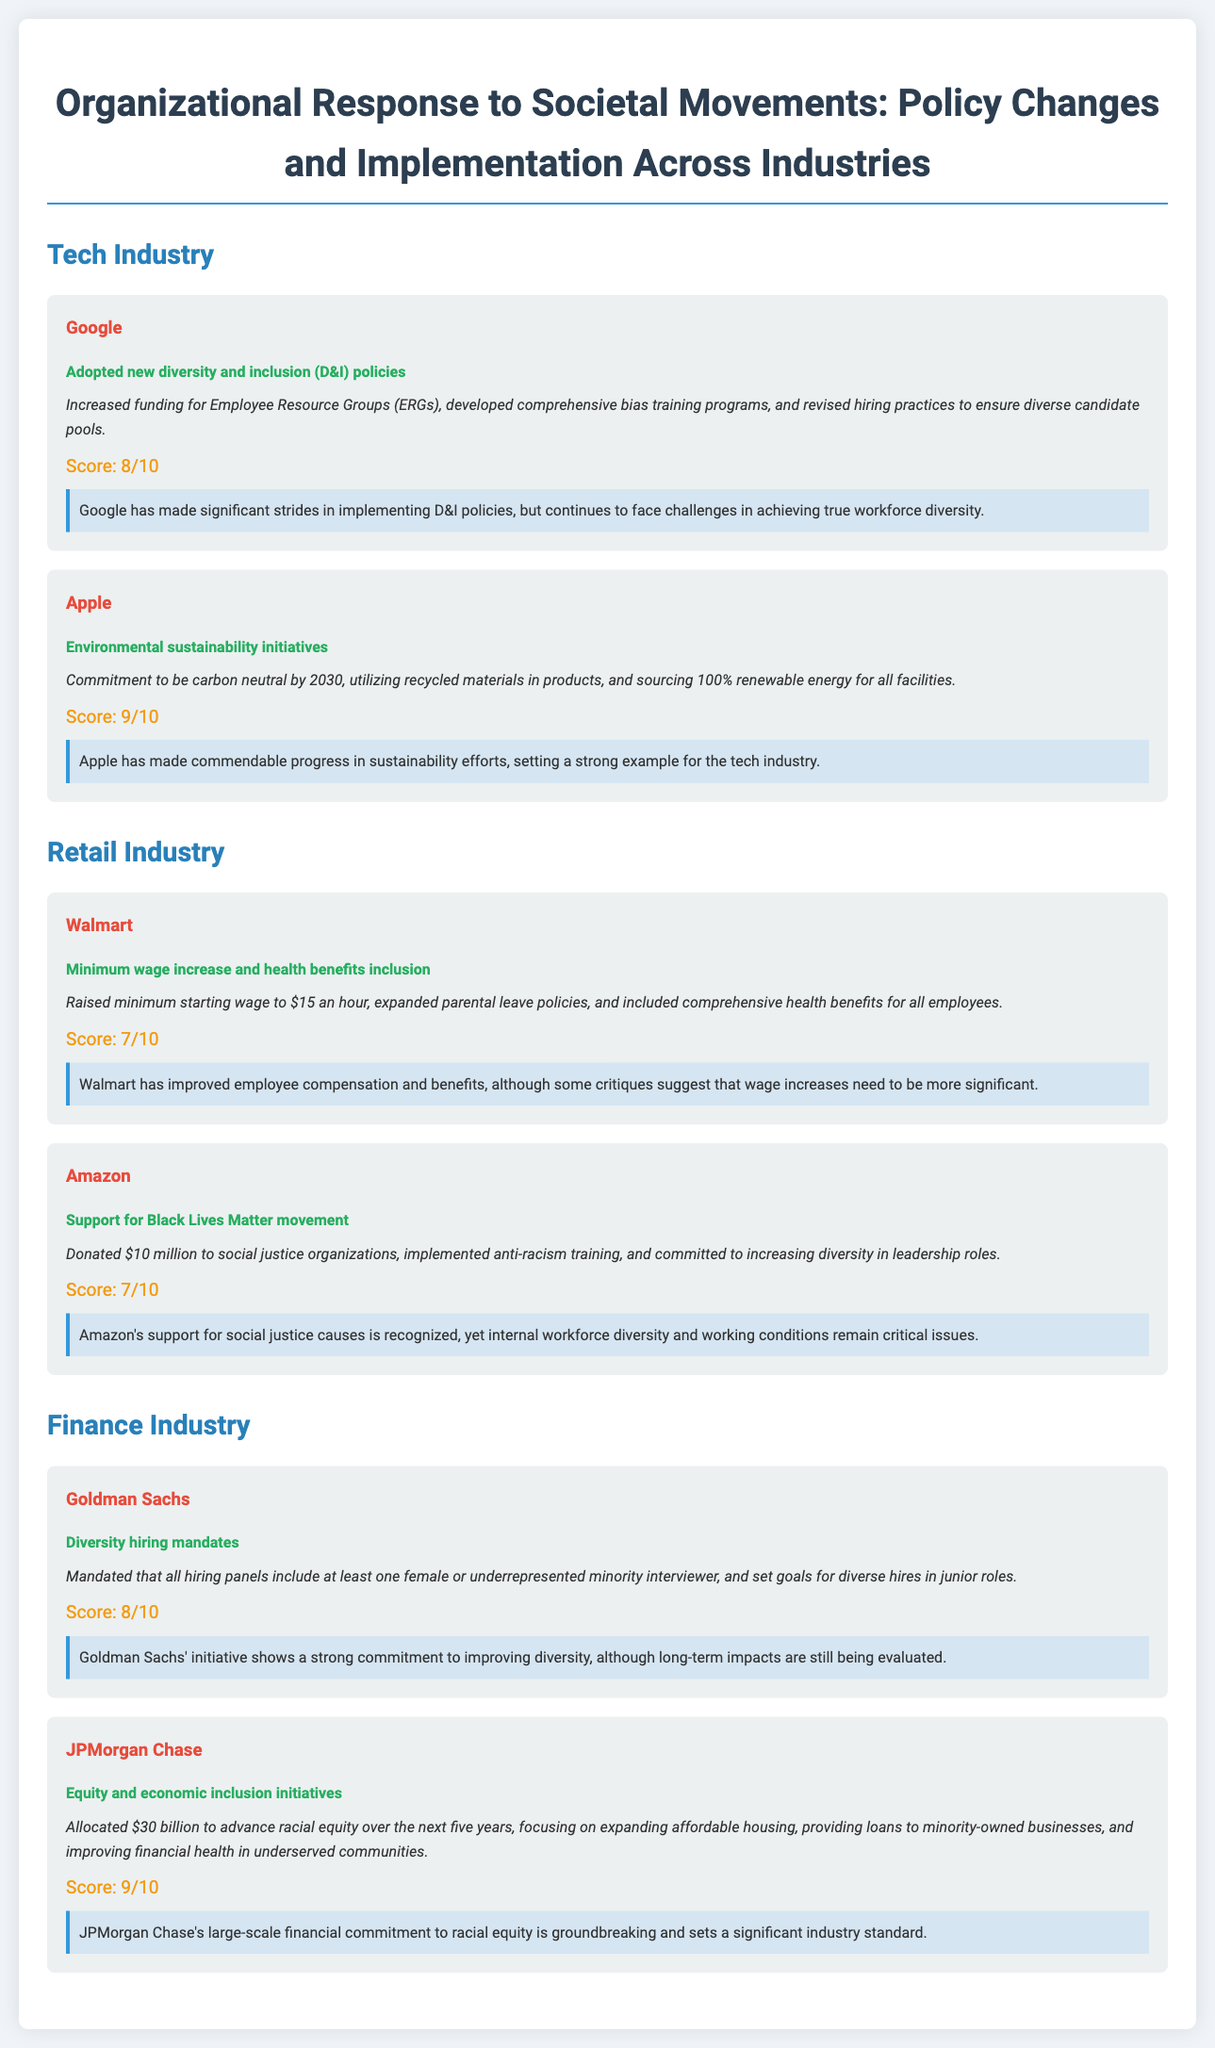What is the score for Google? The score for Google, as indicated in the document, is based on the assessment of their diversity and inclusion policies.
Answer: 8/10 What initiative did Apple commit to by 2030? Apple's commitment, as mentioned in their sustainability initiatives, involves being carbon neutral by a specified year.
Answer: Carbon neutral What was the minimum wage raised to at Walmart? The document specifies that Walmart raised their minimum wage to a specific amount for starting employees.
Answer: $15 How much money did Amazon donate to social justice organizations? The document provides the amount that Amazon contributed to support the Black Lives Matter movement.
Answer: $10 million What is the primary goal of JPMorgan Chase's allocated $30 billion? The scorecard outlines the main purpose of the allocated funds, focusing on advancing racial equity through specific initiatives.
Answer: Racial equity What hiring mandate did Goldman Sachs implement? This question refers to the requirement established by Goldman Sachs for their hiring panels.
Answer: Diversity hiring mandates What type of training did Amazon implement as part of their policy? The document highlights a particular training initiative that Amazon put into place related to social justice.
Answer: Anti-racism training What policy change was introduced by Apple? Apple’s initiative relates to environmental actions taken as part of their corporate responsibility efforts.
Answer: Environmental sustainability initiatives What was Walmart's implementation related to employee benefits? This question requires understanding the benefits Walmart included following their policy changes.
Answer: Comprehensive health benefits 